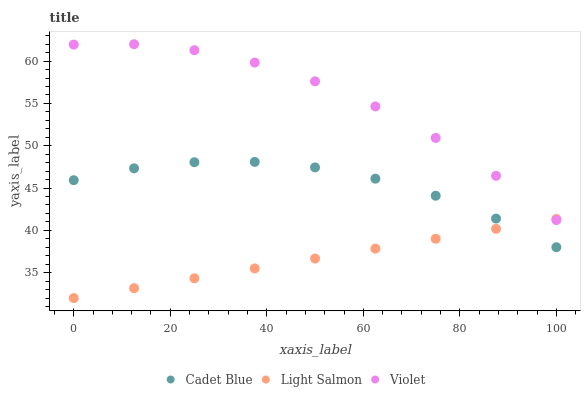Does Light Salmon have the minimum area under the curve?
Answer yes or no. Yes. Does Violet have the maximum area under the curve?
Answer yes or no. Yes. Does Cadet Blue have the minimum area under the curve?
Answer yes or no. No. Does Cadet Blue have the maximum area under the curve?
Answer yes or no. No. Is Light Salmon the smoothest?
Answer yes or no. Yes. Is Violet the roughest?
Answer yes or no. Yes. Is Cadet Blue the smoothest?
Answer yes or no. No. Is Cadet Blue the roughest?
Answer yes or no. No. Does Light Salmon have the lowest value?
Answer yes or no. Yes. Does Cadet Blue have the lowest value?
Answer yes or no. No. Does Violet have the highest value?
Answer yes or no. Yes. Does Cadet Blue have the highest value?
Answer yes or no. No. Is Cadet Blue less than Violet?
Answer yes or no. Yes. Is Violet greater than Cadet Blue?
Answer yes or no. Yes. Does Cadet Blue intersect Light Salmon?
Answer yes or no. Yes. Is Cadet Blue less than Light Salmon?
Answer yes or no. No. Is Cadet Blue greater than Light Salmon?
Answer yes or no. No. Does Cadet Blue intersect Violet?
Answer yes or no. No. 